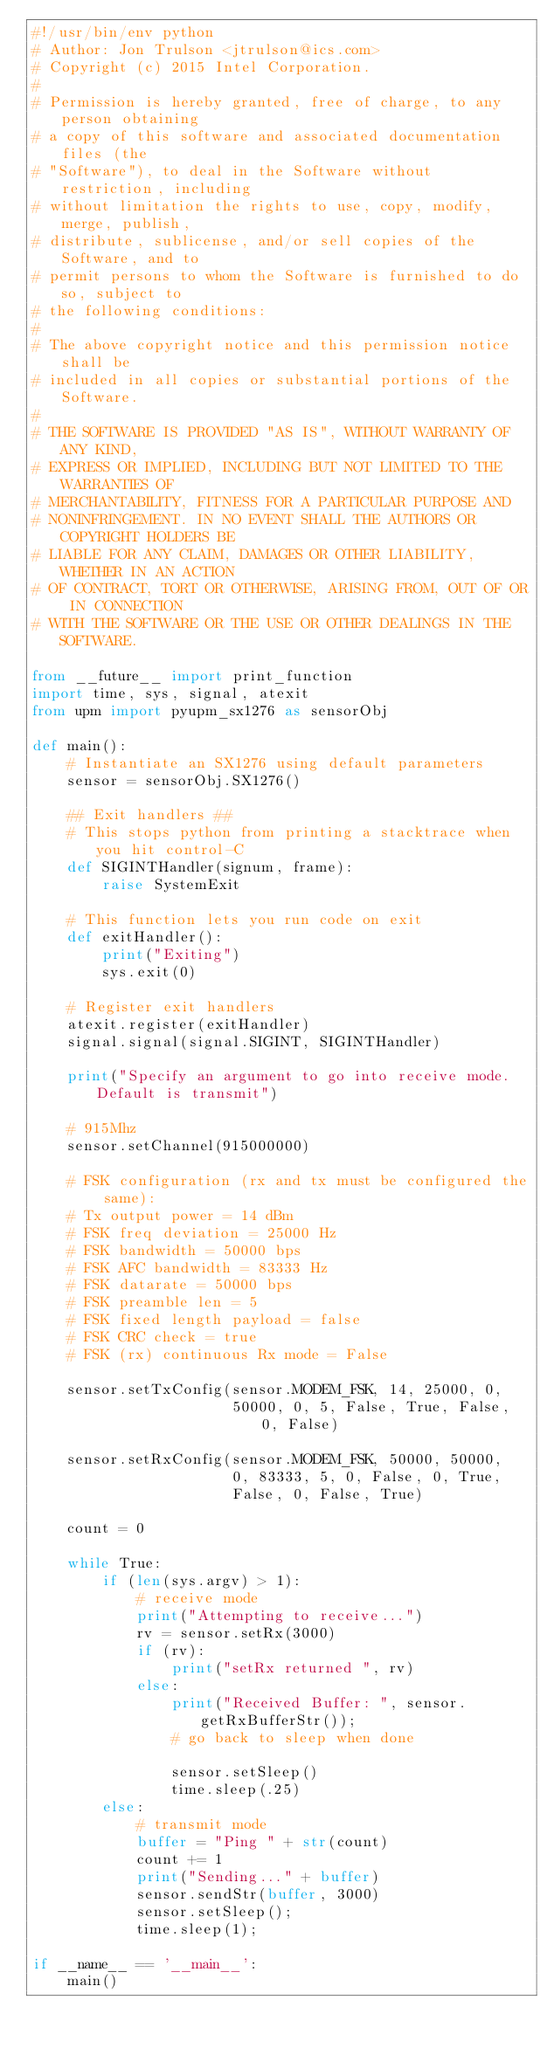Convert code to text. <code><loc_0><loc_0><loc_500><loc_500><_Python_>#!/usr/bin/env python
# Author: Jon Trulson <jtrulson@ics.com>
# Copyright (c) 2015 Intel Corporation.
#
# Permission is hereby granted, free of charge, to any person obtaining
# a copy of this software and associated documentation files (the
# "Software"), to deal in the Software without restriction, including
# without limitation the rights to use, copy, modify, merge, publish,
# distribute, sublicense, and/or sell copies of the Software, and to
# permit persons to whom the Software is furnished to do so, subject to
# the following conditions:
#
# The above copyright notice and this permission notice shall be
# included in all copies or substantial portions of the Software.
#
# THE SOFTWARE IS PROVIDED "AS IS", WITHOUT WARRANTY OF ANY KIND,
# EXPRESS OR IMPLIED, INCLUDING BUT NOT LIMITED TO THE WARRANTIES OF
# MERCHANTABILITY, FITNESS FOR A PARTICULAR PURPOSE AND
# NONINFRINGEMENT. IN NO EVENT SHALL THE AUTHORS OR COPYRIGHT HOLDERS BE
# LIABLE FOR ANY CLAIM, DAMAGES OR OTHER LIABILITY, WHETHER IN AN ACTION
# OF CONTRACT, TORT OR OTHERWISE, ARISING FROM, OUT OF OR IN CONNECTION
# WITH THE SOFTWARE OR THE USE OR OTHER DEALINGS IN THE SOFTWARE.

from __future__ import print_function
import time, sys, signal, atexit
from upm import pyupm_sx1276 as sensorObj

def main():
    # Instantiate an SX1276 using default parameters
    sensor = sensorObj.SX1276()

    ## Exit handlers ##
    # This stops python from printing a stacktrace when you hit control-C
    def SIGINTHandler(signum, frame):
        raise SystemExit

    # This function lets you run code on exit
    def exitHandler():
        print("Exiting")
        sys.exit(0)

    # Register exit handlers
    atexit.register(exitHandler)
    signal.signal(signal.SIGINT, SIGINTHandler)

    print("Specify an argument to go into receive mode.  Default is transmit")

    # 915Mhz
    sensor.setChannel(915000000)

    # FSK configuration (rx and tx must be configured the same):
    # Tx output power = 14 dBm
    # FSK freq deviation = 25000 Hz
    # FSK bandwidth = 50000 bps
    # FSK AFC bandwidth = 83333 Hz
    # FSK datarate = 50000 bps
    # FSK preamble len = 5
    # FSK fixed length payload = false
    # FSK CRC check = true
    # FSK (rx) continuous Rx mode = False

    sensor.setTxConfig(sensor.MODEM_FSK, 14, 25000, 0,
                       50000, 0, 5, False, True, False, 0, False)

    sensor.setRxConfig(sensor.MODEM_FSK, 50000, 50000,
                       0, 83333, 5, 0, False, 0, True,
                       False, 0, False, True)

    count = 0

    while True:
        if (len(sys.argv) > 1):
            # receive mode
            print("Attempting to receive...")
            rv = sensor.setRx(3000)
            if (rv):
                print("setRx returned ", rv)
            else:
                print("Received Buffer: ", sensor.getRxBufferStr());
                # go back to sleep when done

                sensor.setSleep()
                time.sleep(.25)
        else:
            # transmit mode
            buffer = "Ping " + str(count)
            count += 1
            print("Sending..." + buffer)
            sensor.sendStr(buffer, 3000)
            sensor.setSleep();
            time.sleep(1);

if __name__ == '__main__':
    main()
</code> 